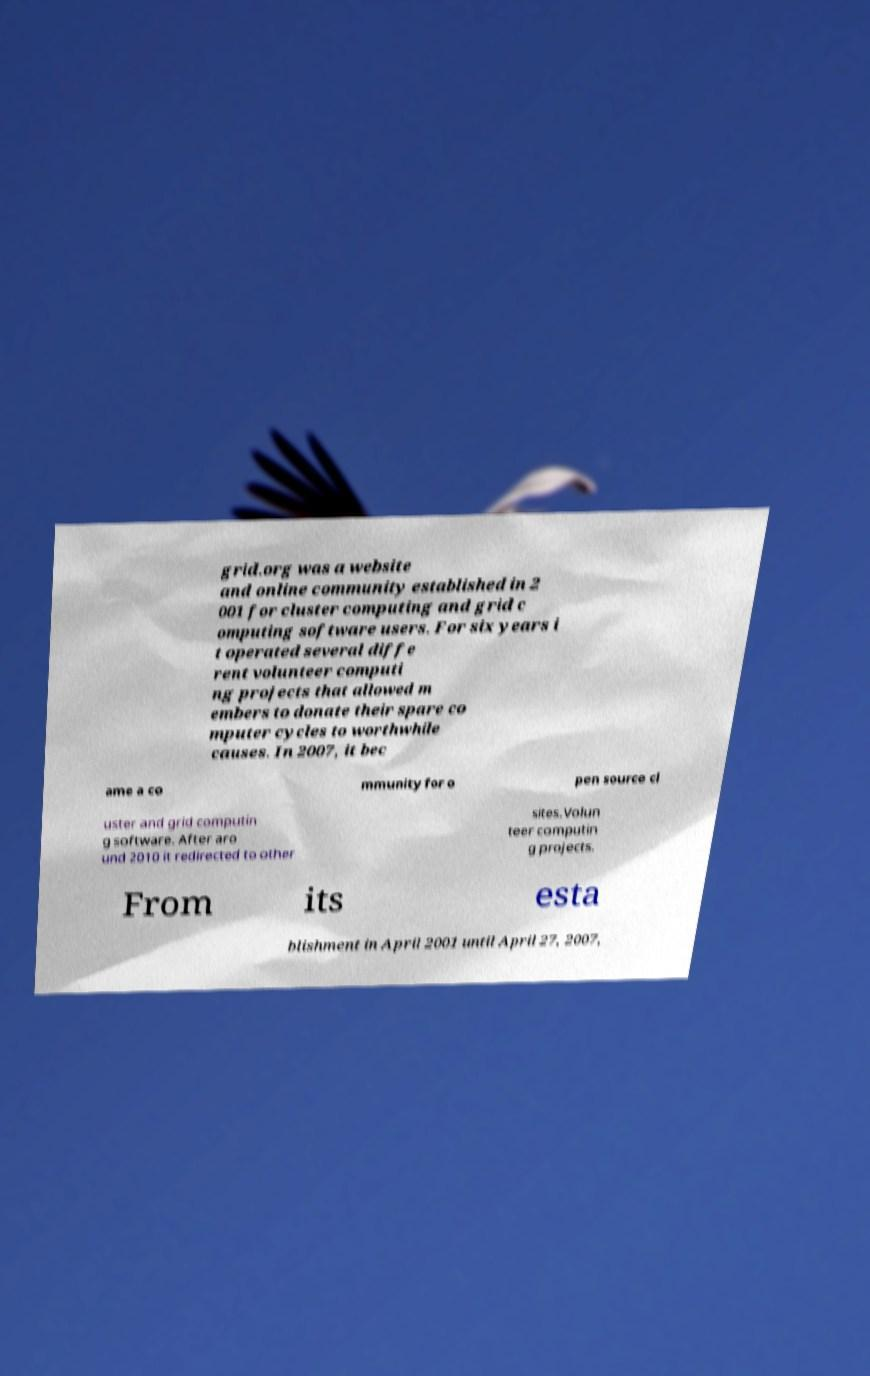I need the written content from this picture converted into text. Can you do that? grid.org was a website and online community established in 2 001 for cluster computing and grid c omputing software users. For six years i t operated several diffe rent volunteer computi ng projects that allowed m embers to donate their spare co mputer cycles to worthwhile causes. In 2007, it bec ame a co mmunity for o pen source cl uster and grid computin g software. After aro und 2010 it redirected to other sites.Volun teer computin g projects. From its esta blishment in April 2001 until April 27, 2007, 